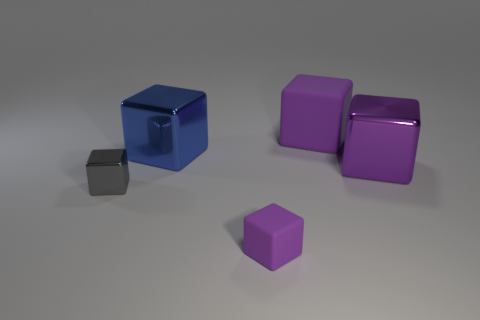How many purple cubes must be subtracted to get 1 purple cubes? 2 Add 5 large blue objects. How many objects exist? 10 Subtract all small purple cubes. How many cubes are left? 4 Subtract all gray blocks. How many blocks are left? 4 Subtract 0 brown blocks. How many objects are left? 5 Subtract 3 cubes. How many cubes are left? 2 Subtract all green cubes. Subtract all gray spheres. How many cubes are left? 5 Subtract all blue spheres. How many purple blocks are left? 3 Subtract all small red cubes. Subtract all purple cubes. How many objects are left? 2 Add 2 small purple rubber cubes. How many small purple rubber cubes are left? 3 